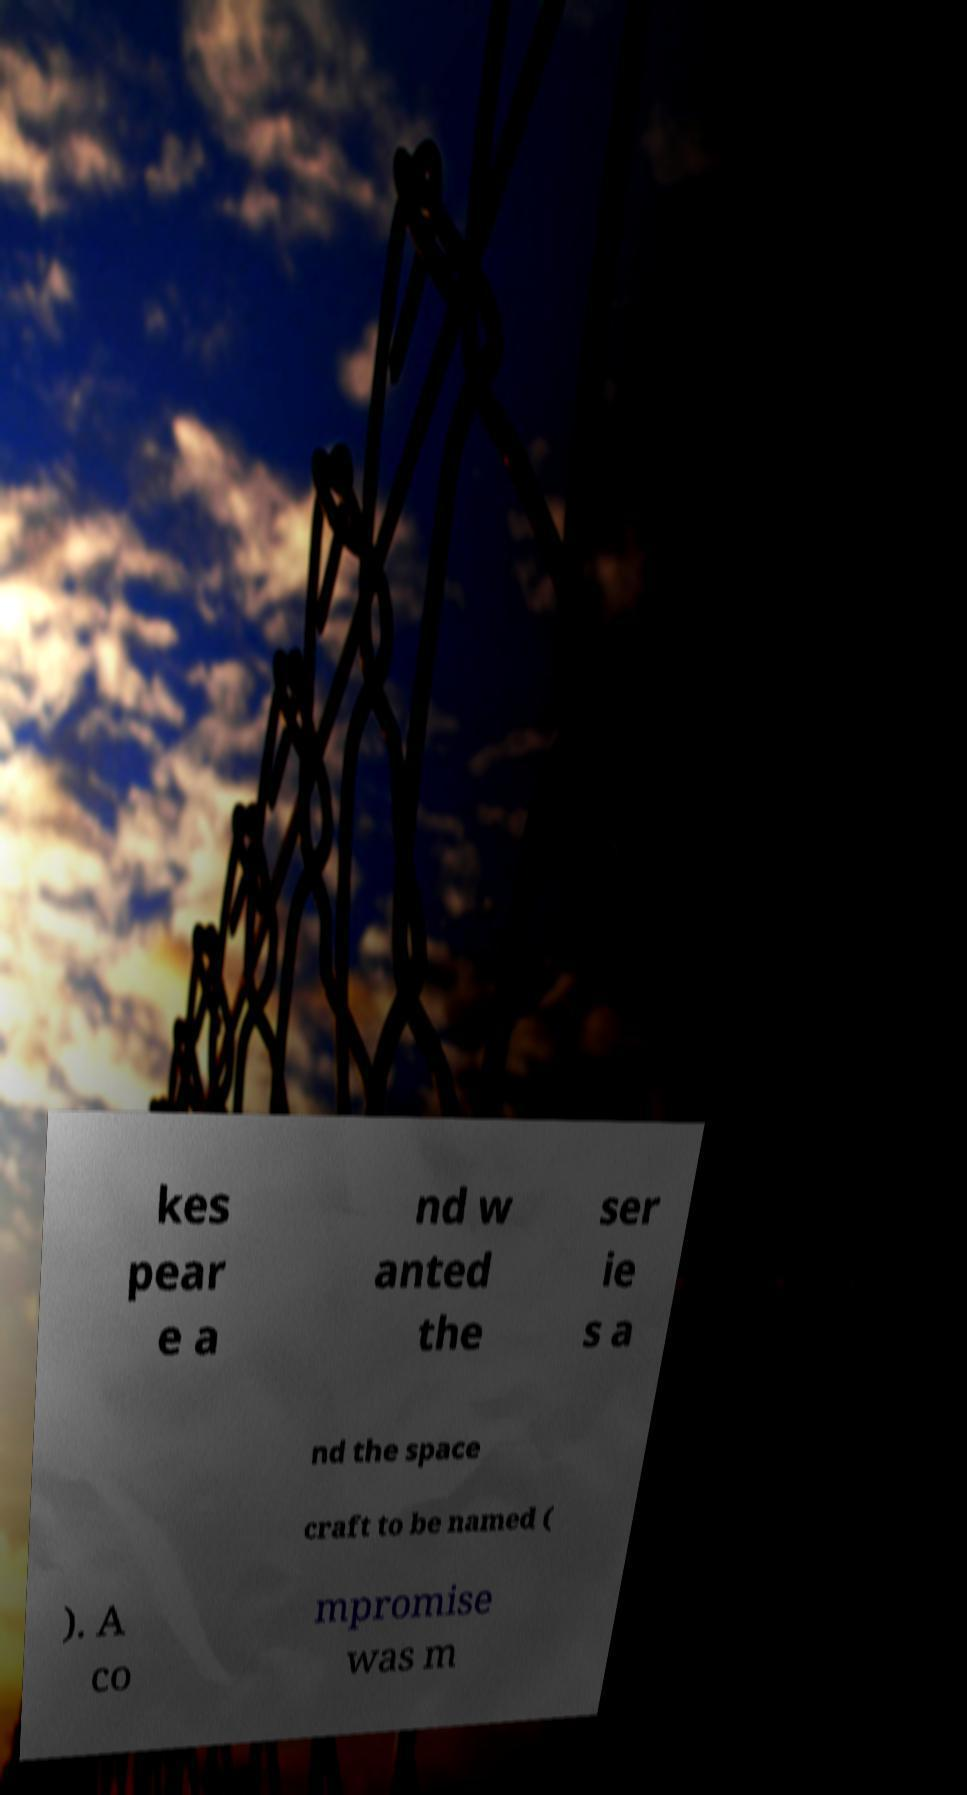Please identify and transcribe the text found in this image. kes pear e a nd w anted the ser ie s a nd the space craft to be named ( ). A co mpromise was m 